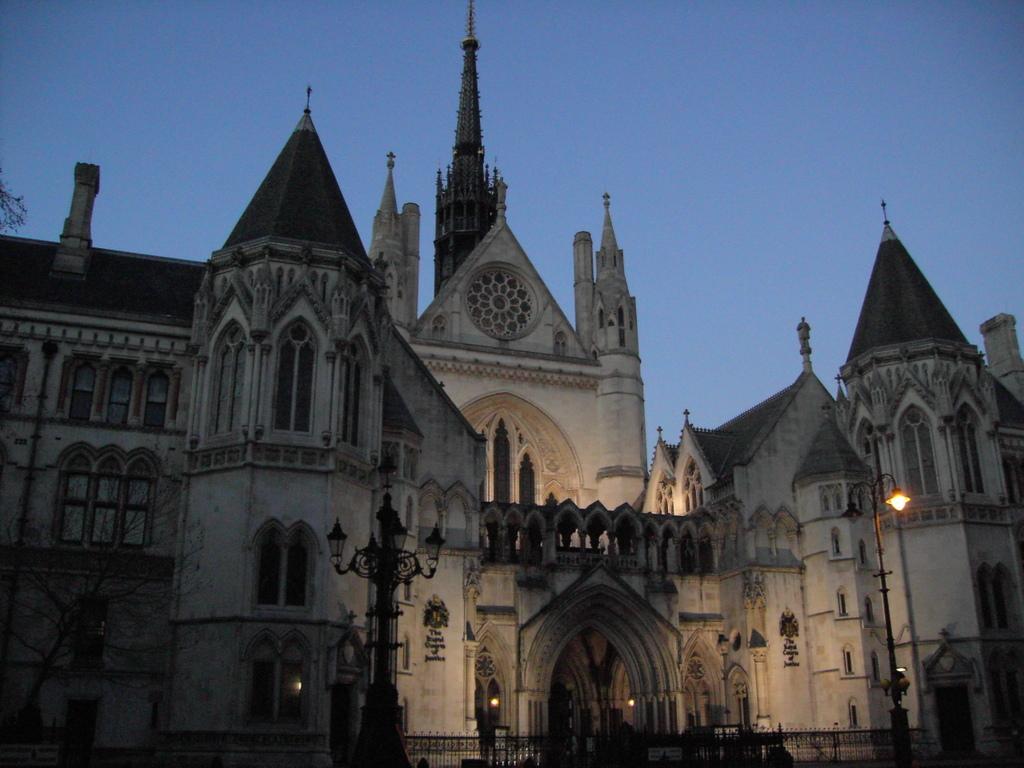Please provide a concise description of this image. In this image in the front there are poles and there is a fence in the center. In the background there is a castle and on the left side there is a tree. 